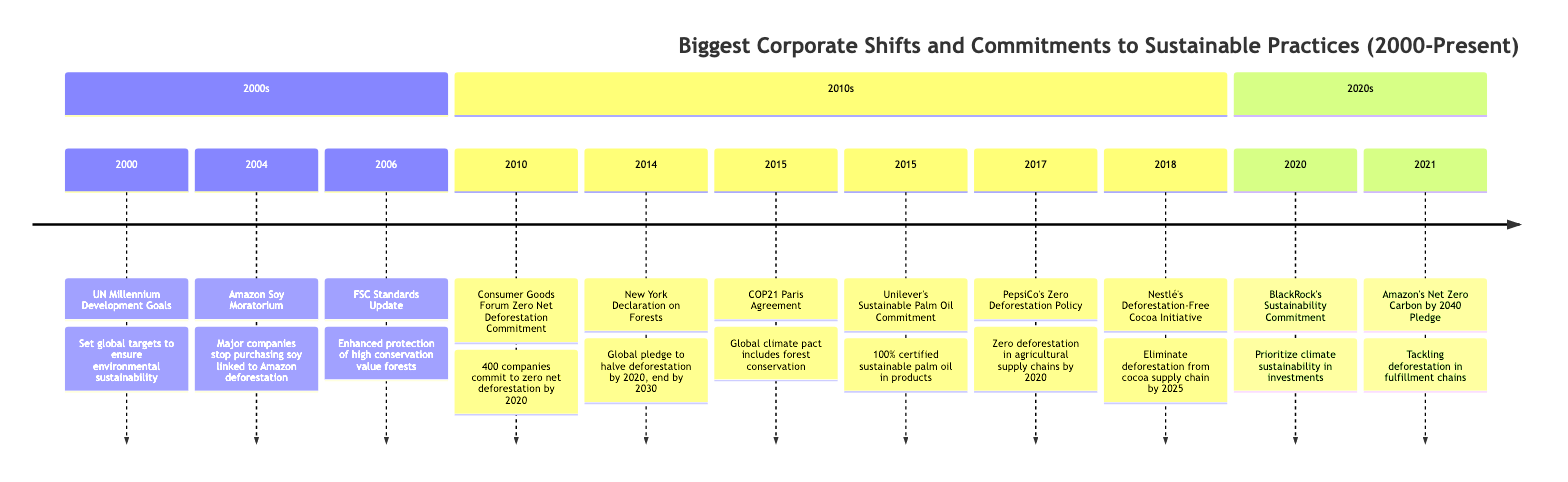What event occurred in 2004? The timeline shows that in 2004, the Amazon Soy Moratorium was implemented, where major companies agreed to stop purchasing soy linked to Amazon deforestation.
Answer: Amazon Soy Moratorium How many companies committed to zero net deforestation in 2010? According to the timeline, in 2010, 400 companies committed to achieving zero net deforestation in their supply chains.
Answer: 400 What is the goal of the New York Declaration on Forests? The timeline states that the New York Declaration on Forests aimed to halve deforestation by 2020 and end it by 2030. This clarifies the intended goals outlined in this event.
Answer: Halve deforestation by 2020, end it by 2030 What significant event occurred in 2015 related to global climate policy? The timeline indicates that in 2015, the COP21 Paris Agreement was established, which included commitments to conserve and enhance forests as carbon sinks.
Answer: COP21 Paris Agreement Which company pledged to eliminate deforestation from its cocoa supply chain by 2025? The timeline shows that in 2018, Nestlé pledged to eliminate deforestation from its cocoa supply chain by 2025, making it clear which company made this commitment.
Answer: Nestlé What was a major milestone that companies agreed upon in 2010? The timeline reveals that in 2010, the Consumer Goods Forum Zero Net Deforestation Commitment was made, where 400 companies pledged to achieve zero net deforestation by 2020.
Answer: Zero Net Deforestation Commitment In what year did BlackRock announce its sustainability commitment? According to the timeline, BlackRock announced its sustainability commitment in 2020, marking an important shift towards climate sustainability in investments.
Answer: 2020 Which company achieved 100% certified sustainable palm oil in 2015? The timeline indicates that Unilever achieved 100% certified sustainable palm oil in its products in 2015, highlighting its commitment to reducing deforestation.
Answer: Unilever 